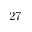Convert formula to latex. <formula><loc_0><loc_0><loc_500><loc_500>2 7</formula> 